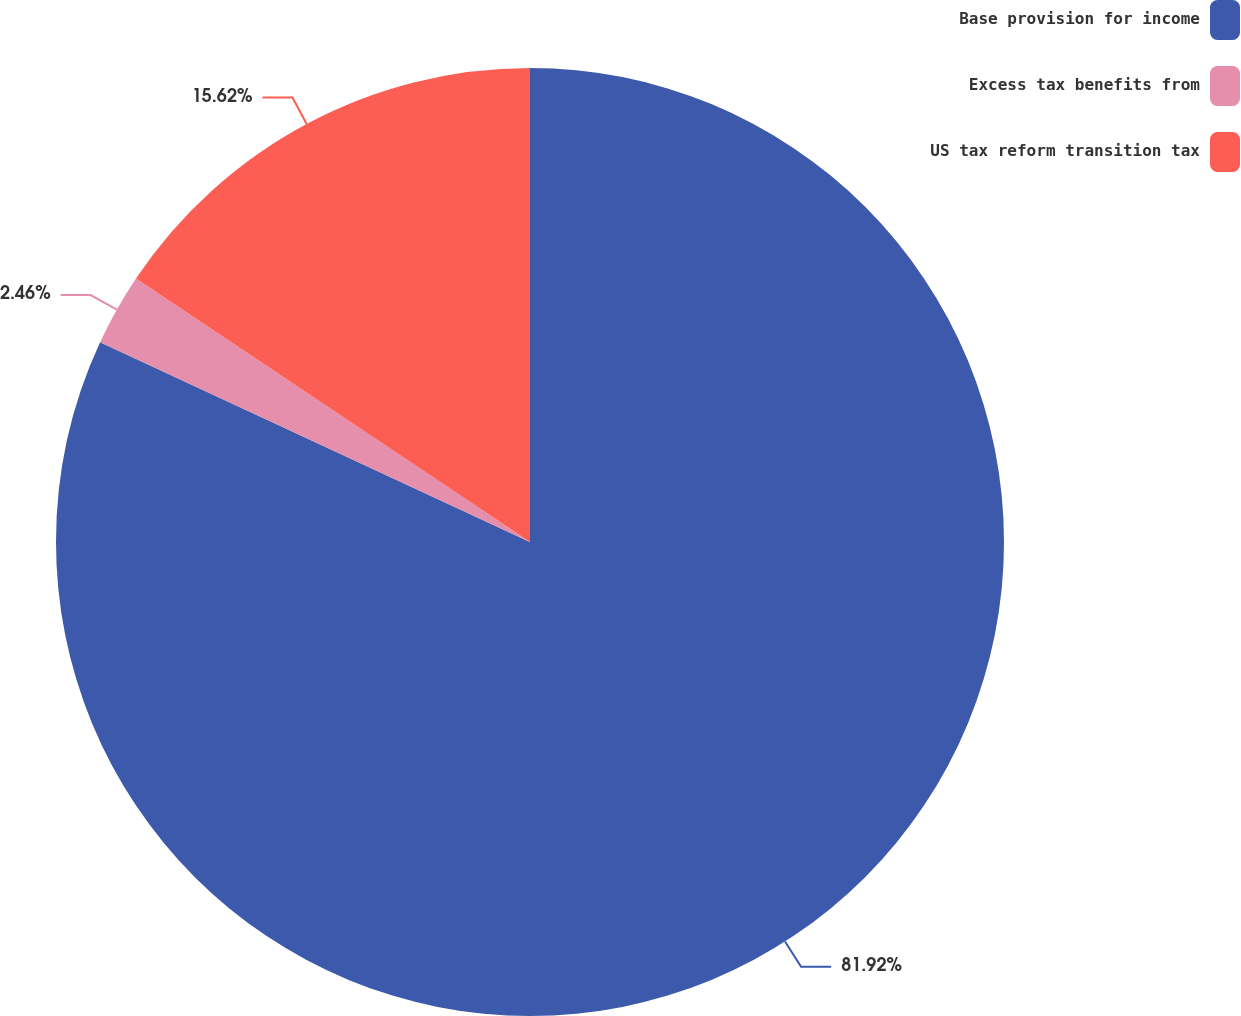Convert chart. <chart><loc_0><loc_0><loc_500><loc_500><pie_chart><fcel>Base provision for income<fcel>Excess tax benefits from<fcel>US tax reform transition tax<nl><fcel>81.92%<fcel>2.46%<fcel>15.62%<nl></chart> 